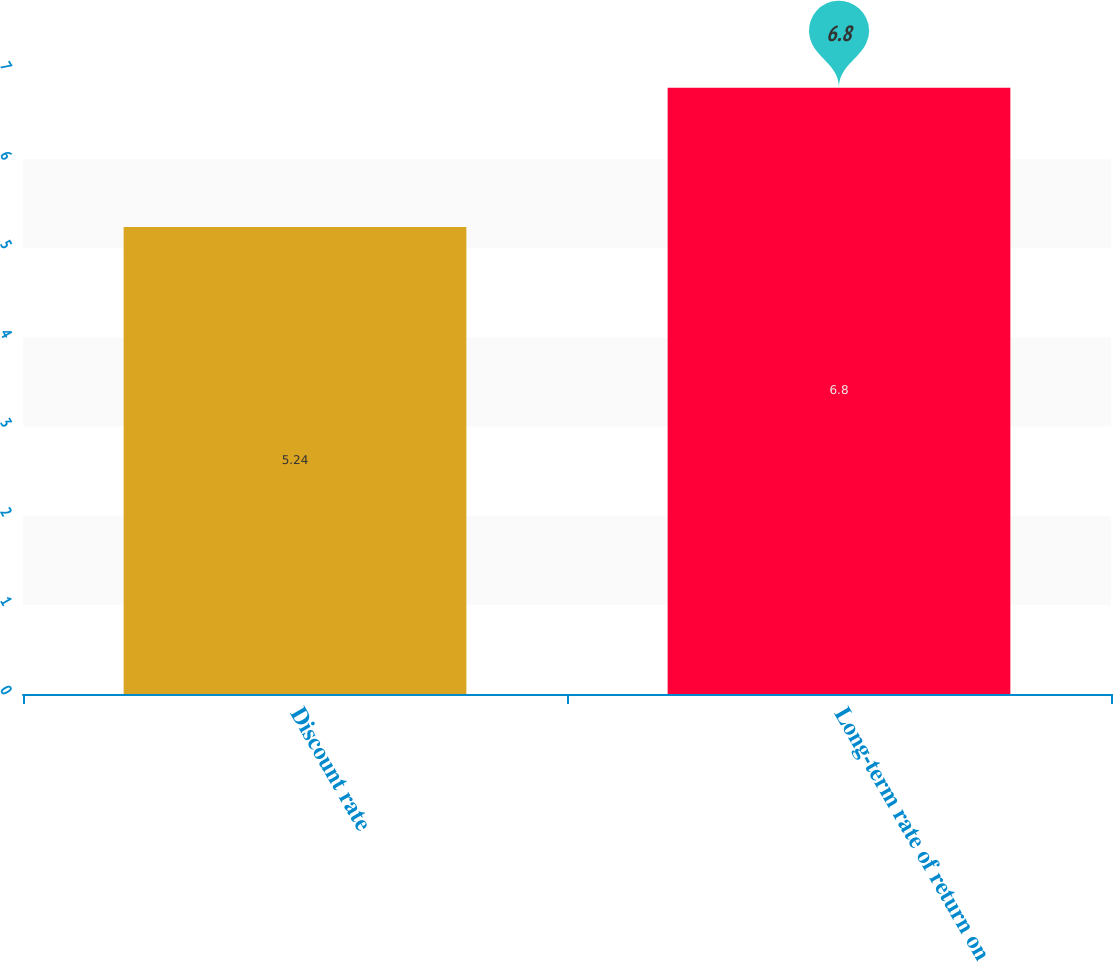Convert chart to OTSL. <chart><loc_0><loc_0><loc_500><loc_500><bar_chart><fcel>Discount rate<fcel>Long-term rate of return on<nl><fcel>5.24<fcel>6.8<nl></chart> 